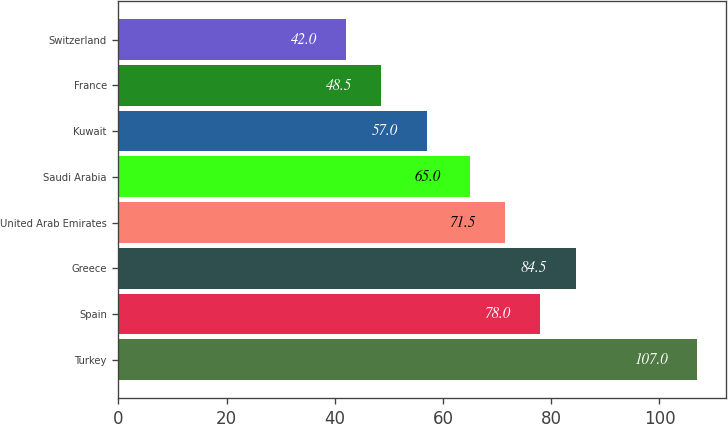Convert chart to OTSL. <chart><loc_0><loc_0><loc_500><loc_500><bar_chart><fcel>Turkey<fcel>Spain<fcel>Greece<fcel>United Arab Emirates<fcel>Saudi Arabia<fcel>Kuwait<fcel>France<fcel>Switzerland<nl><fcel>107<fcel>78<fcel>84.5<fcel>71.5<fcel>65<fcel>57<fcel>48.5<fcel>42<nl></chart> 